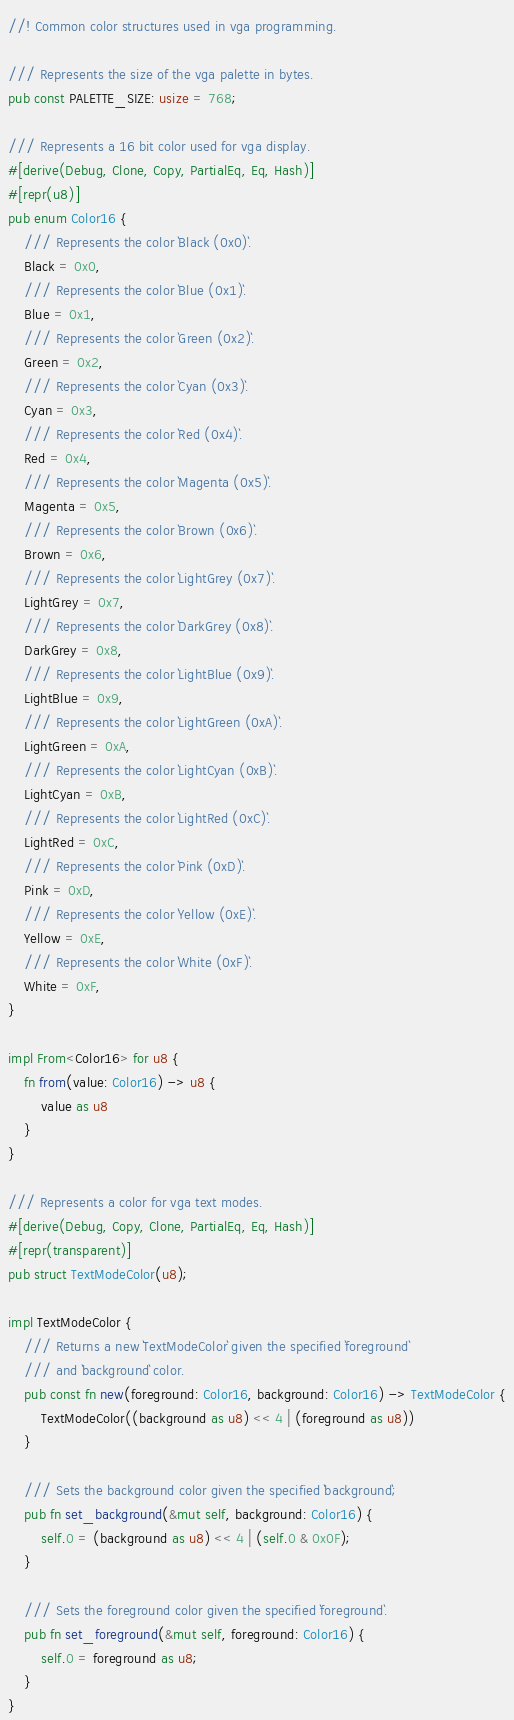<code> <loc_0><loc_0><loc_500><loc_500><_Rust_>//! Common color structures used in vga programming.

/// Represents the size of the vga palette in bytes.
pub const PALETTE_SIZE: usize = 768;

/// Represents a 16 bit color used for vga display.
#[derive(Debug, Clone, Copy, PartialEq, Eq, Hash)]
#[repr(u8)]
pub enum Color16 {
    /// Represents the color `Black (0x0)`.
    Black = 0x0,
    /// Represents the color `Blue (0x1)`.
    Blue = 0x1,
    /// Represents the color `Green (0x2)`.
    Green = 0x2,
    /// Represents the color `Cyan (0x3)`.
    Cyan = 0x3,
    /// Represents the color `Red (0x4)`.
    Red = 0x4,
    /// Represents the color `Magenta (0x5)`.
    Magenta = 0x5,
    /// Represents the color `Brown (0x6)`.
    Brown = 0x6,
    /// Represents the color `LightGrey (0x7)`.
    LightGrey = 0x7,
    /// Represents the color `DarkGrey (0x8)`.
    DarkGrey = 0x8,
    /// Represents the color `LightBlue (0x9)`.
    LightBlue = 0x9,
    /// Represents the color `LightGreen (0xA)`.
    LightGreen = 0xA,
    /// Represents the color `LightCyan (0xB)`.
    LightCyan = 0xB,
    /// Represents the color `LightRed (0xC)`.
    LightRed = 0xC,
    /// Represents the color `Pink (0xD)`.
    Pink = 0xD,
    /// Represents the color `Yellow (0xE)`.
    Yellow = 0xE,
    /// Represents the color `White (0xF)`.
    White = 0xF,
}

impl From<Color16> for u8 {
    fn from(value: Color16) -> u8 {
        value as u8
    }
}

/// Represents a color for vga text modes.
#[derive(Debug, Copy, Clone, PartialEq, Eq, Hash)]
#[repr(transparent)]
pub struct TextModeColor(u8);

impl TextModeColor {
    /// Returns a new `TextModeColor` given the specified `foreground`
    /// and `background` color.
    pub const fn new(foreground: Color16, background: Color16) -> TextModeColor {
        TextModeColor((background as u8) << 4 | (foreground as u8))
    }

    /// Sets the background color given the specified `background`;
    pub fn set_background(&mut self, background: Color16) {
        self.0 = (background as u8) << 4 | (self.0 & 0x0F);
    }

    /// Sets the foreground color given the specified `foreground`.
    pub fn set_foreground(&mut self, foreground: Color16) {
        self.0 = foreground as u8;
    }
}
</code> 